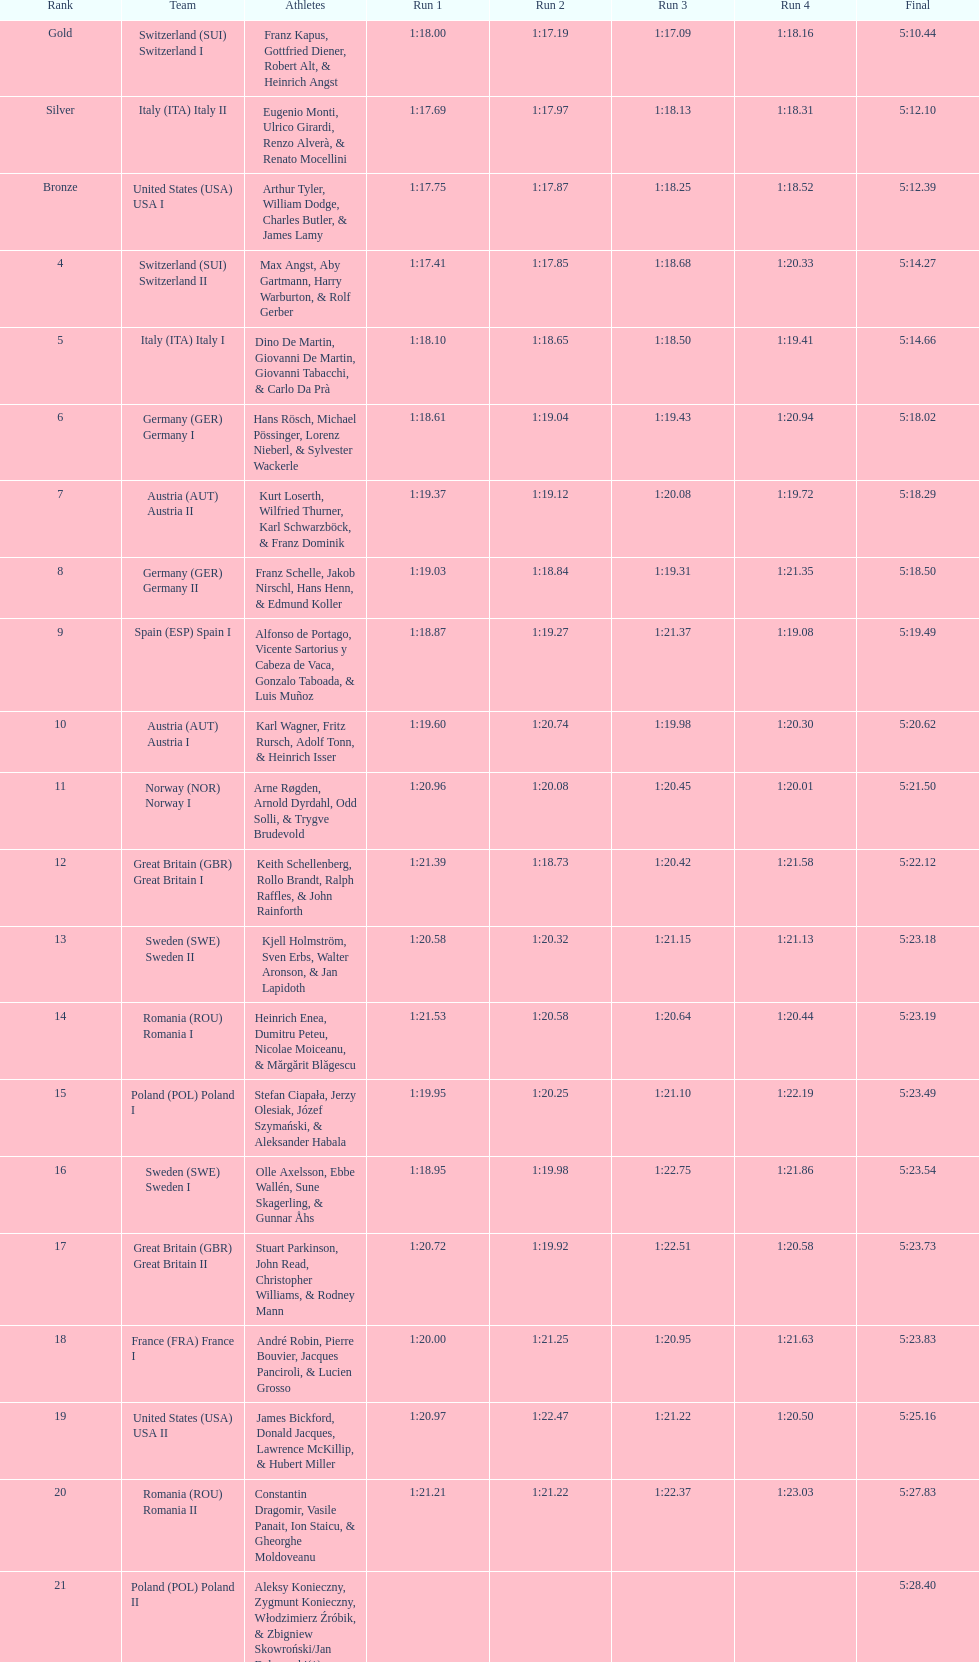What team came out on top? Switzerland. 